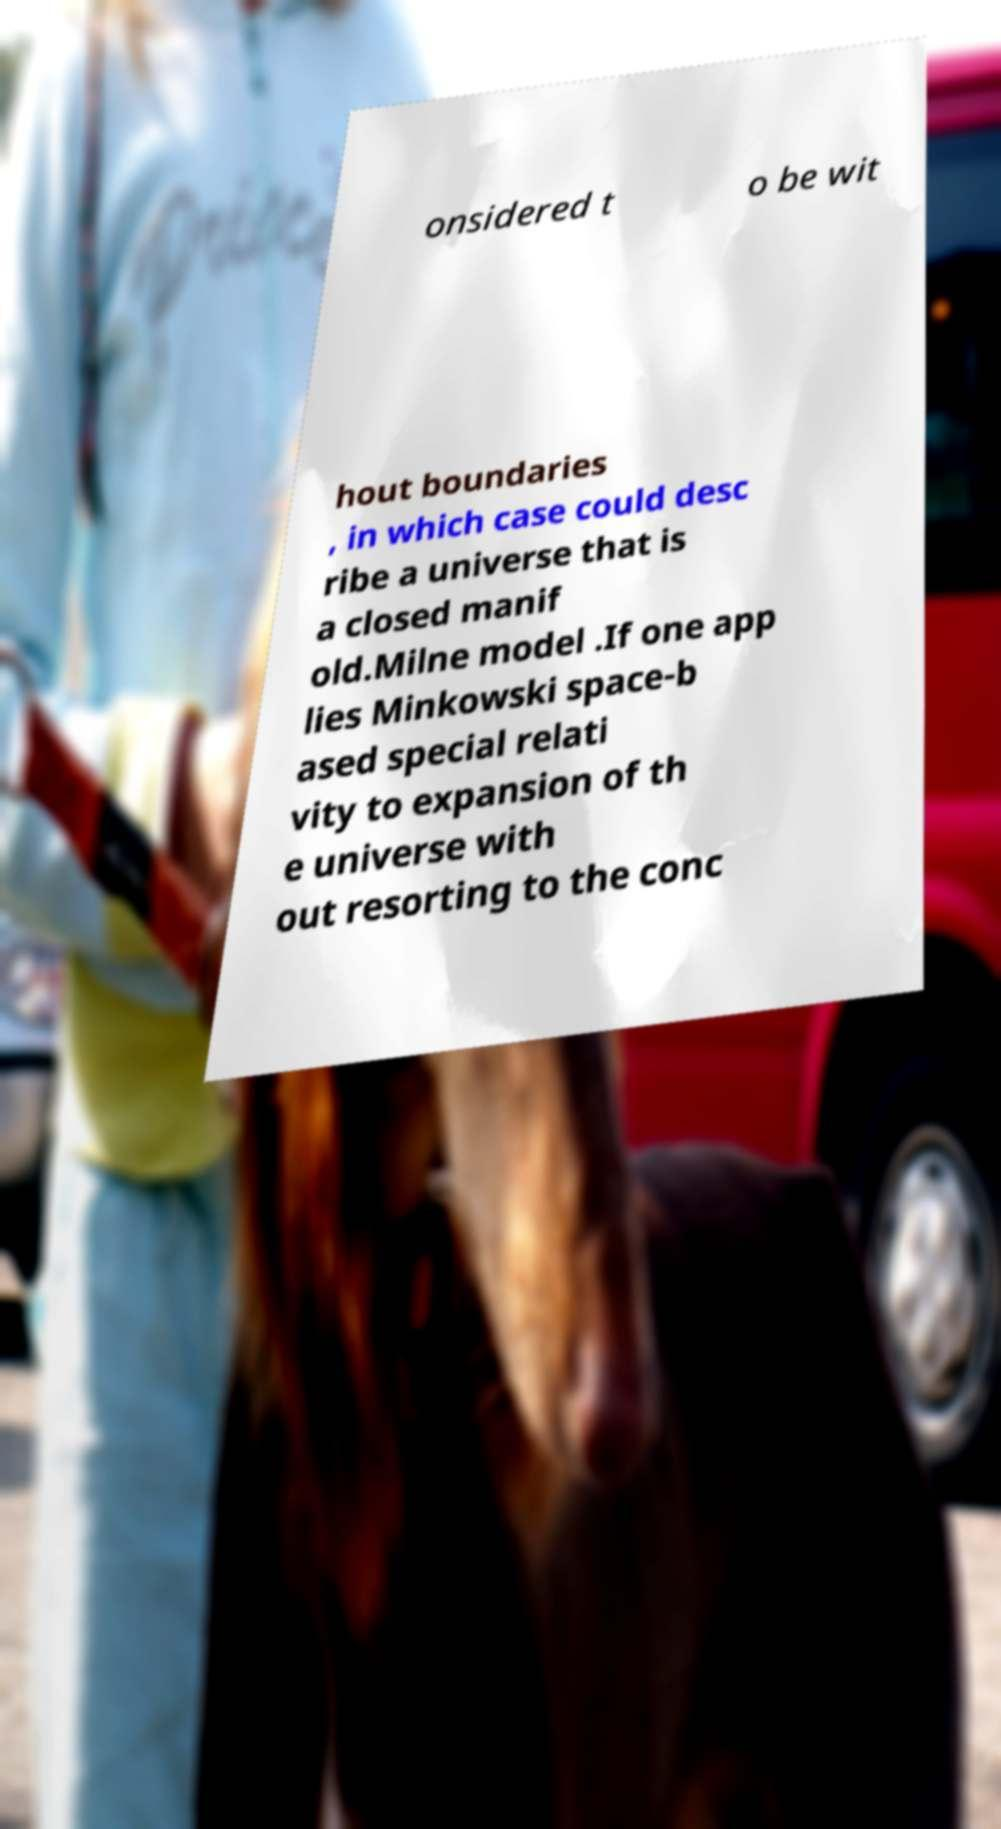Can you read and provide the text displayed in the image?This photo seems to have some interesting text. Can you extract and type it out for me? onsidered t o be wit hout boundaries , in which case could desc ribe a universe that is a closed manif old.Milne model .If one app lies Minkowski space-b ased special relati vity to expansion of th e universe with out resorting to the conc 